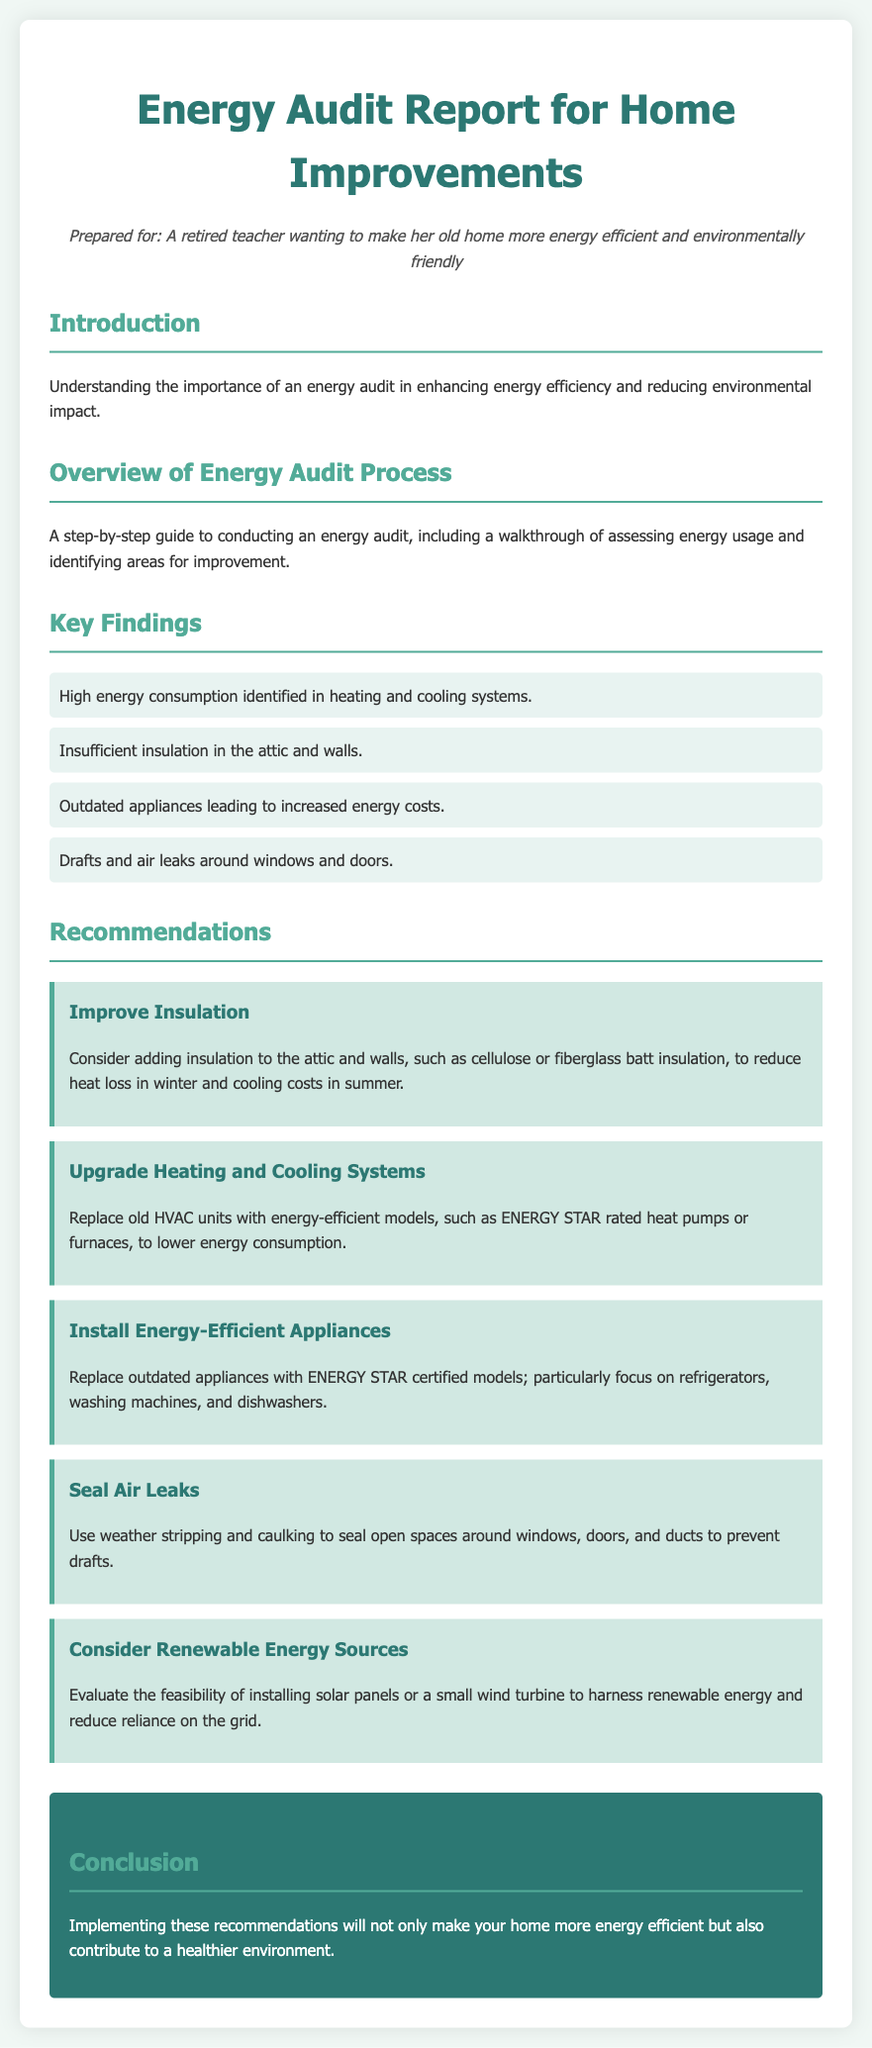What is the title of the document? The title of the document is specified at the beginning of the HTML code, which states the content is an energy audit report.
Answer: Energy Audit Report for Home Improvements Who is the report prepared for? The document includes a persona section that describes the intended recipient of the report.
Answer: A retired teacher wanting to make her old home more energy efficient and environmentally friendly What is one of the key findings regarding insulation? The document lists key findings, one of which relates to the state of insulation in the home.
Answer: Insufficient insulation in the attic and walls What is one of the recommended actions for energy efficiency? The recommendations section provides multiple actions; one is specifically about insulation.
Answer: Improve Insulation Which type of appliances should be upgraded according to the recommendations? The recommendations suggest specific types of appliances that should be replaced to enhance energy efficiency.
Answer: Energy-efficient appliances What color is the conclusion section? The document describes the style of the conclusion section, including its background color.
Answer: #2c7873 How many main recommendations are provided? The recommendations section outlines several different improvements to make the home more efficient.
Answer: Five What type of systems should be replaced? The recommendations focus on specific systems that may be outdated and inefficient in the home.
Answer: Heating and cooling systems 